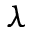Convert formula to latex. <formula><loc_0><loc_0><loc_500><loc_500>\lambda</formula> 